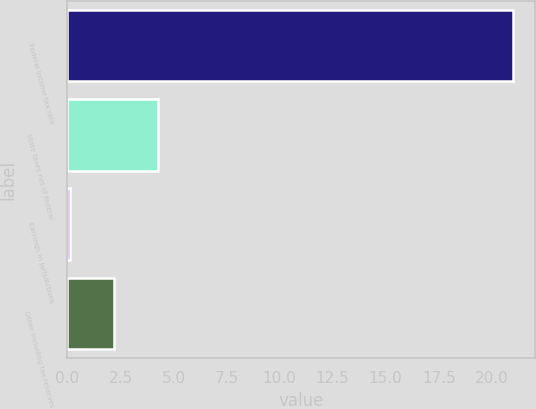<chart> <loc_0><loc_0><loc_500><loc_500><bar_chart><fcel>Federal income tax rate<fcel>State taxes net of federal<fcel>Earnings in jurisdictions<fcel>Other including tax reserves<nl><fcel>21<fcel>4.28<fcel>0.1<fcel>2.19<nl></chart> 